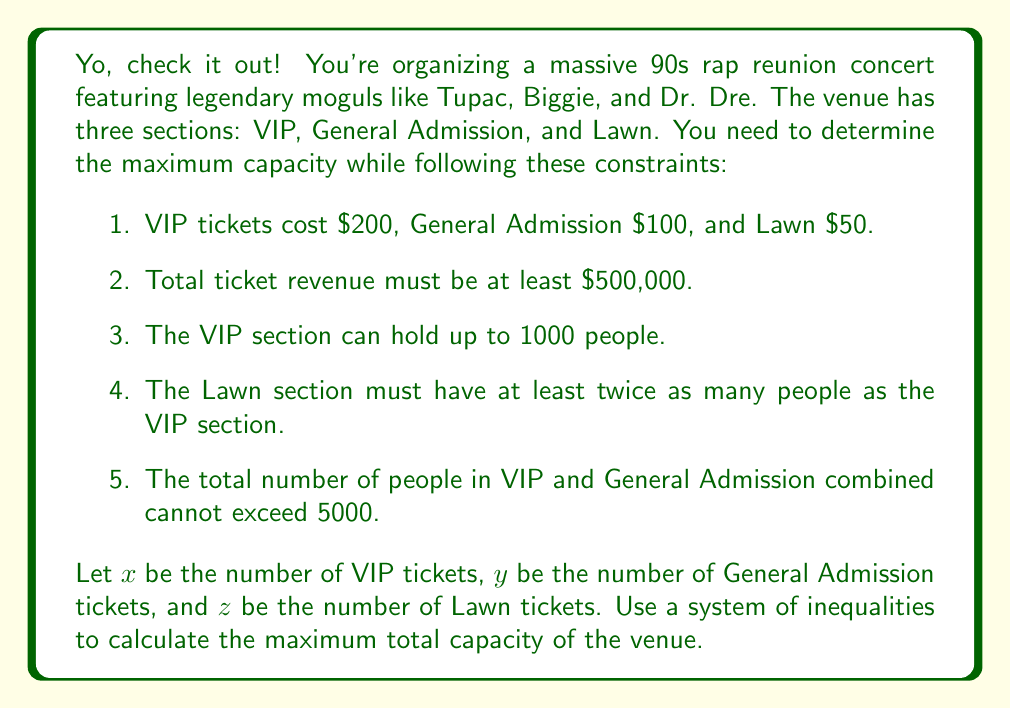Help me with this question. Alright, let's break this down step by step:

1. First, we need to set up our system of inequalities based on the given constraints:

   a) Revenue constraint: $200x + 100y + 50z \geq 500000$
   b) VIP capacity: $x \leq 1000$
   c) Lawn vs VIP: $z \geq 2x$
   d) VIP and General Admission limit: $x + y \leq 5000$
   e) Non-negativity: $x \geq 0, y \geq 0, z \geq 0$

2. Our objective is to maximize the total capacity, which is $x + y + z$.

3. To solve this, we can use the vertex method. The maximum will occur at one of the vertices of the feasible region defined by our inequalities.

4. Let's consider the vertices:

   - When $x = 1000$ (max VIP):
     From (c), $z \geq 2000$
     From (d), $y \leq 4000$
     Plugging into (a): $200(1000) + 100(4000) + 50(2000) = 800000 \geq 500000$
     This satisfies all constraints.

   - When $x + y = 5000$ and $z = 2x$:
     Let $x = 1000, y = 4000, z = 2000$
     This is the same as the previous case.

   - When revenue is exactly $500000:
     $200x + 100y + 50z = 500000$
     This could give a lower total capacity, so we don't need to consider it.

5. Therefore, the maximum capacity occurs when:
   $x = 1000$ (VIP)
   $y = 4000$ (General Admission)
   $z = 2000$ (Lawn)

6. The total maximum capacity is $1000 + 4000 + 2000 = 7000$.
Answer: The maximum total capacity of the venue is 7000 people. 